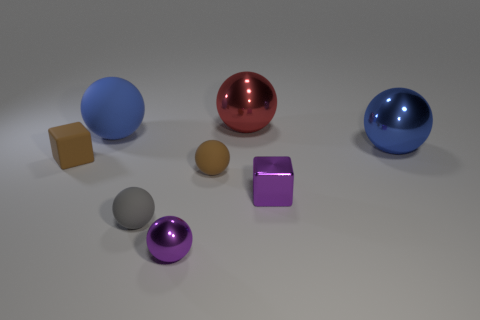Subtract all gray balls. How many balls are left? 5 Subtract all blue spheres. How many spheres are left? 4 Subtract 3 balls. How many balls are left? 3 Subtract all green spheres. Subtract all purple cylinders. How many spheres are left? 6 Add 2 yellow shiny blocks. How many objects exist? 10 Subtract all blocks. How many objects are left? 6 Subtract all large blue matte blocks. Subtract all big red metal spheres. How many objects are left? 7 Add 7 large red metal spheres. How many large red metal spheres are left? 8 Add 1 brown matte blocks. How many brown matte blocks exist? 2 Subtract 0 purple cylinders. How many objects are left? 8 